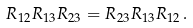<formula> <loc_0><loc_0><loc_500><loc_500>R _ { 1 2 } R _ { 1 3 } R _ { 2 3 } = R _ { 2 3 } R _ { 1 3 } R _ { 1 2 } \, .</formula> 